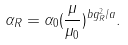Convert formula to latex. <formula><loc_0><loc_0><loc_500><loc_500>\alpha _ { R } = \alpha _ { 0 } ( \frac { \mu } { \mu _ { 0 } } ) ^ { b g _ { R } ^ { 2 } / a } .</formula> 